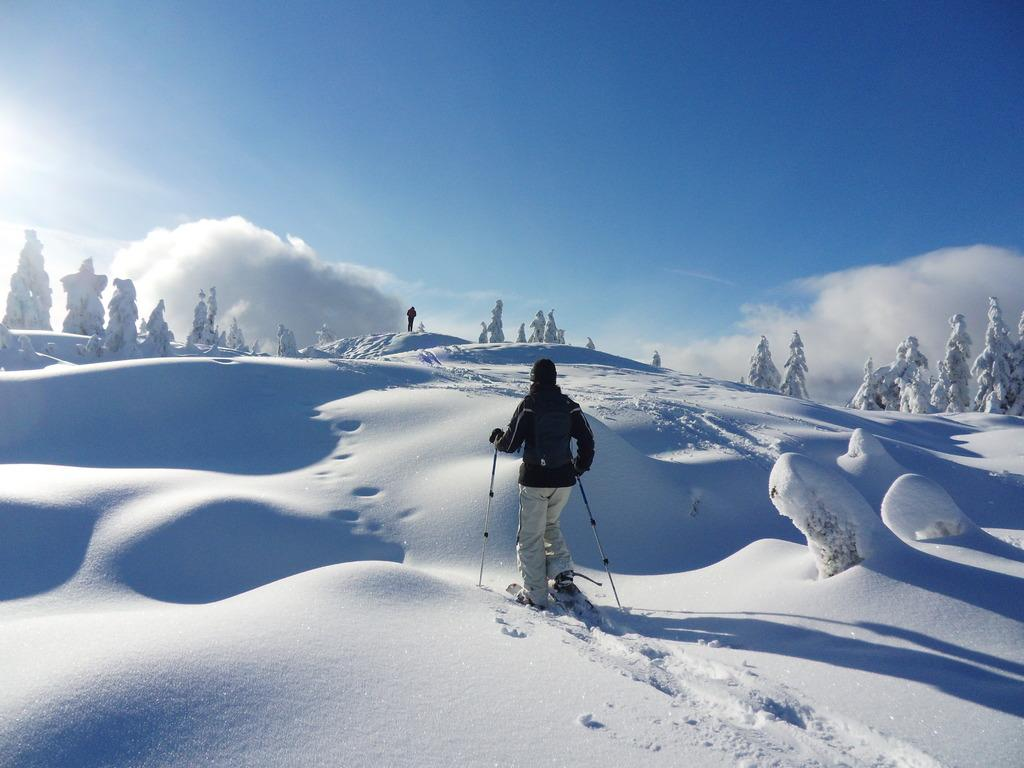What is the person in the image doing? The person is standing in the image and is wearing skis. What equipment is the person holding in the image? The person is holding ski sticks in the image. Can you describe the background of the image? There is another person and trees in the backdrop of the image. What is the condition of the sky in the image? The sky is clear in the image. What type of copper material can be seen on the page in the image? There is no copper or page present in the image; it features a person wearing skis and ski sticks, with a clear sky and trees in the backdrop. 